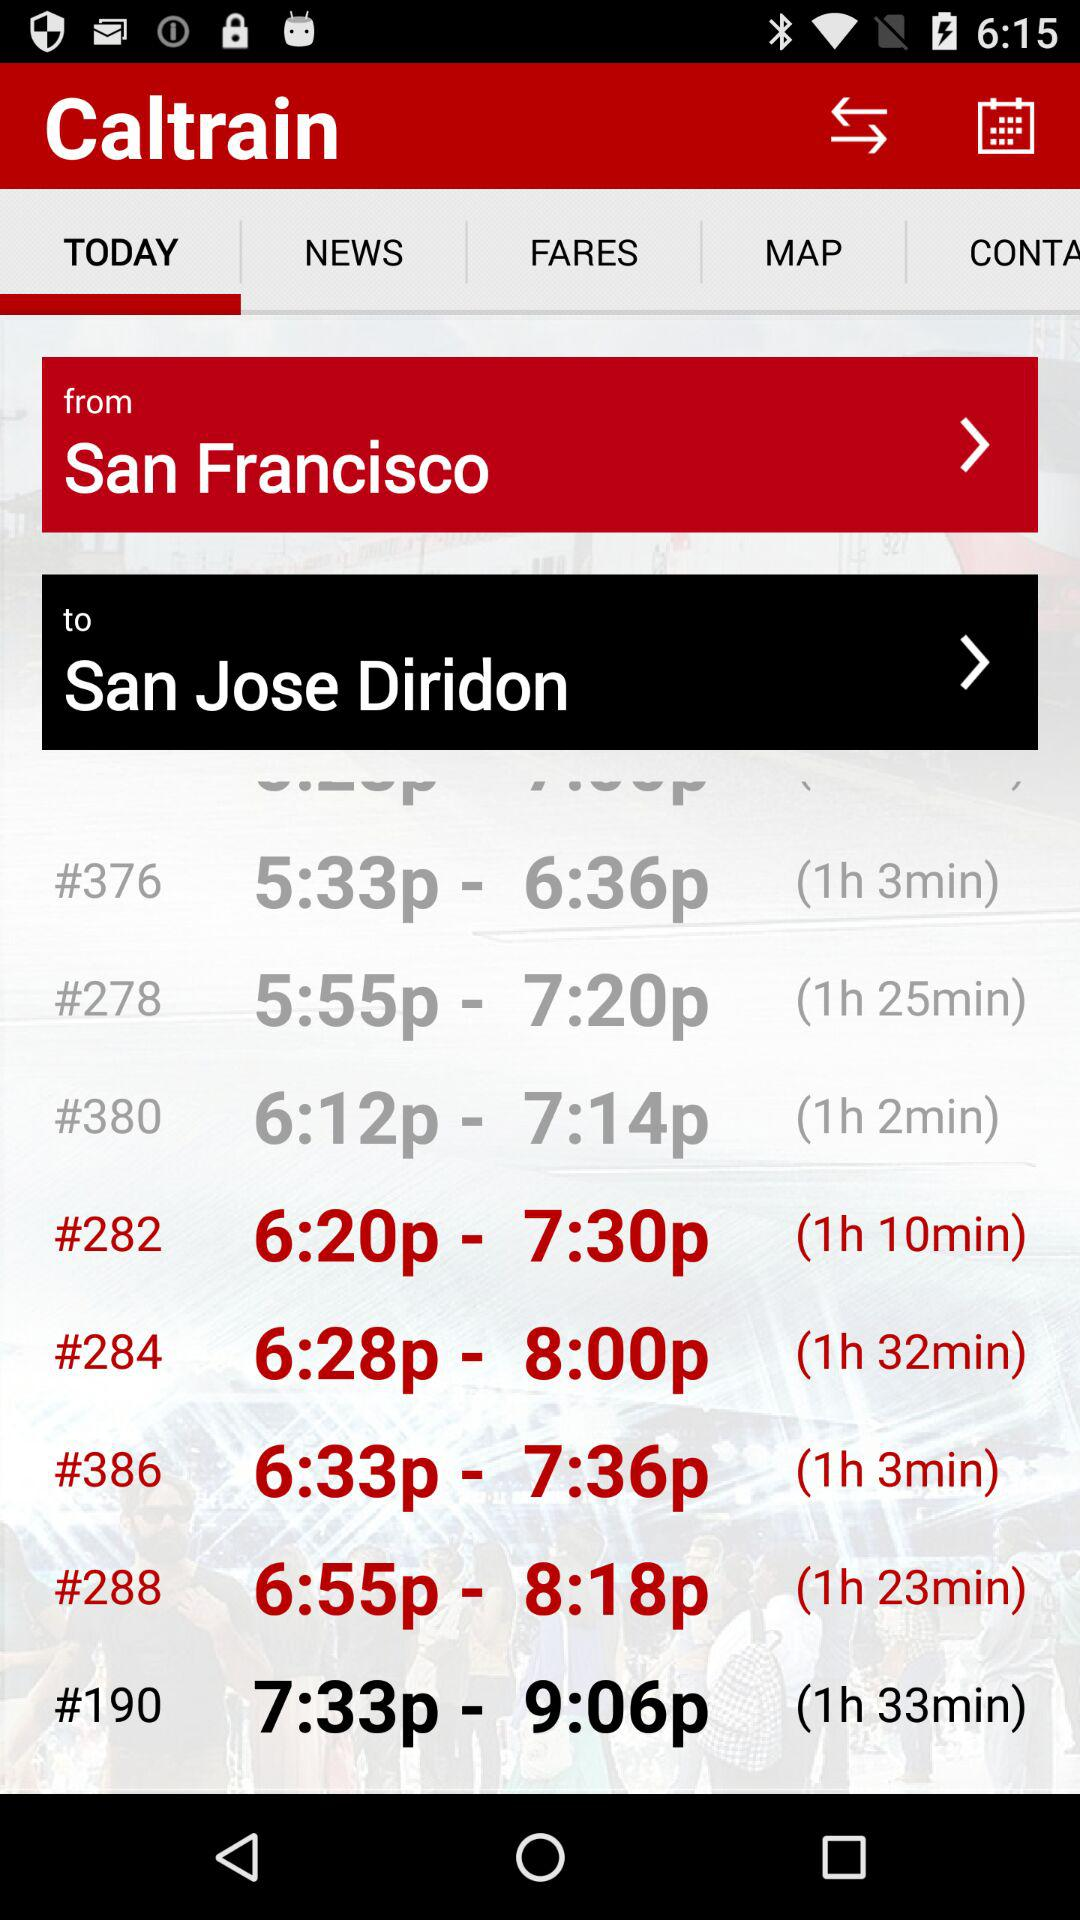What is the location from where the journey starts? The location is San Francisco. 